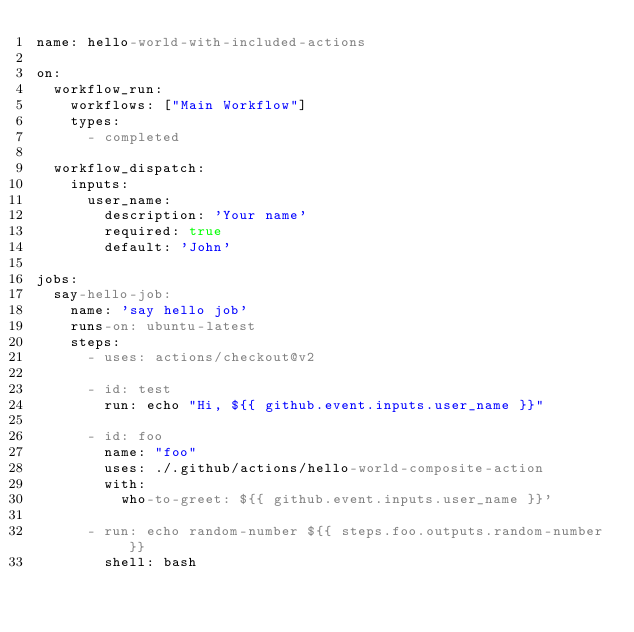<code> <loc_0><loc_0><loc_500><loc_500><_YAML_>name: hello-world-with-included-actions

on:
  workflow_run:
    workflows: ["Main Workflow"]
    types:
      - completed

  workflow_dispatch:
    inputs:
      user_name:
        description: 'Your name'
        required: true
        default: 'John'

jobs:
  say-hello-job:
    name: 'say hello job'
    runs-on: ubuntu-latest
    steps:
      - uses: actions/checkout@v2

      - id: test
        run: echo "Hi, ${{ github.event.inputs.user_name }}"

      - id: foo
        name: "foo"
        uses: ./.github/actions/hello-world-composite-action
        with:
          who-to-greet: ${{ github.event.inputs.user_name }}'

      - run: echo random-number ${{ steps.foo.outputs.random-number }}
        shell: bash</code> 